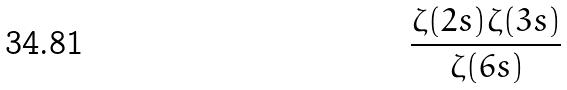<formula> <loc_0><loc_0><loc_500><loc_500>\frac { \zeta ( 2 s ) \zeta ( 3 s ) } { \zeta ( 6 s ) }</formula> 